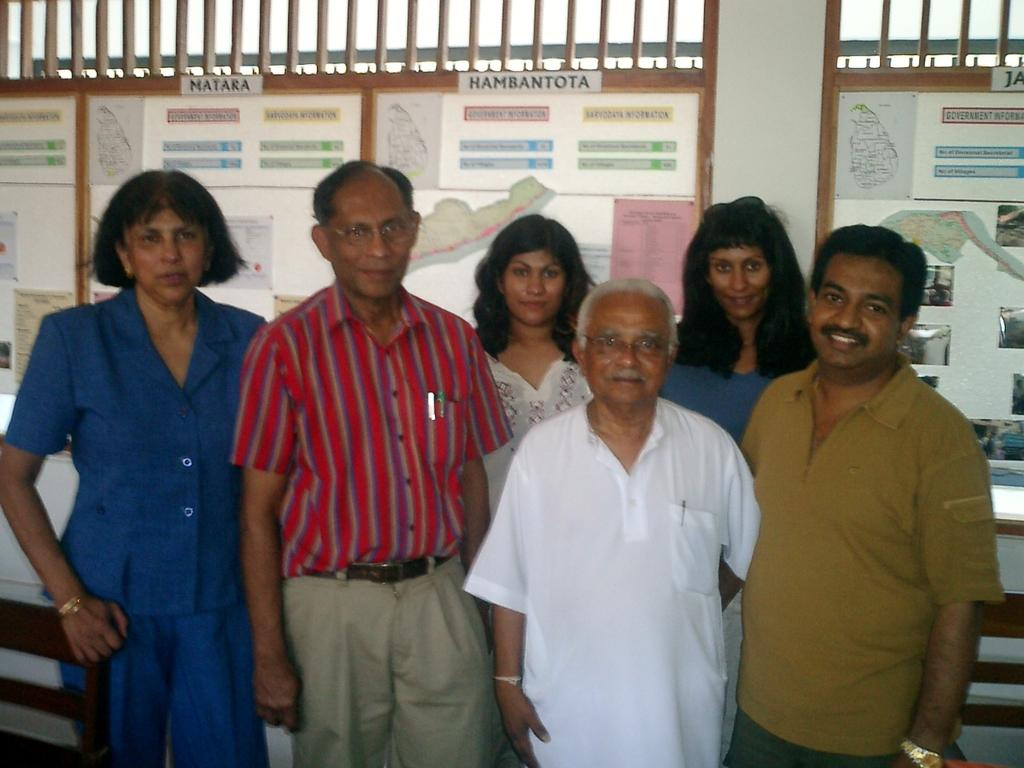What is present in the image? There are people standing in the image. What can be seen in the background of the image? There is a wall with text in the background of the image. What type of form is the cork used for in the image? There is no cork present in the image. How many men are visible in the image? The provided facts do not specify the gender of the people in the image, so it cannot be definitively determined if there are men present. 